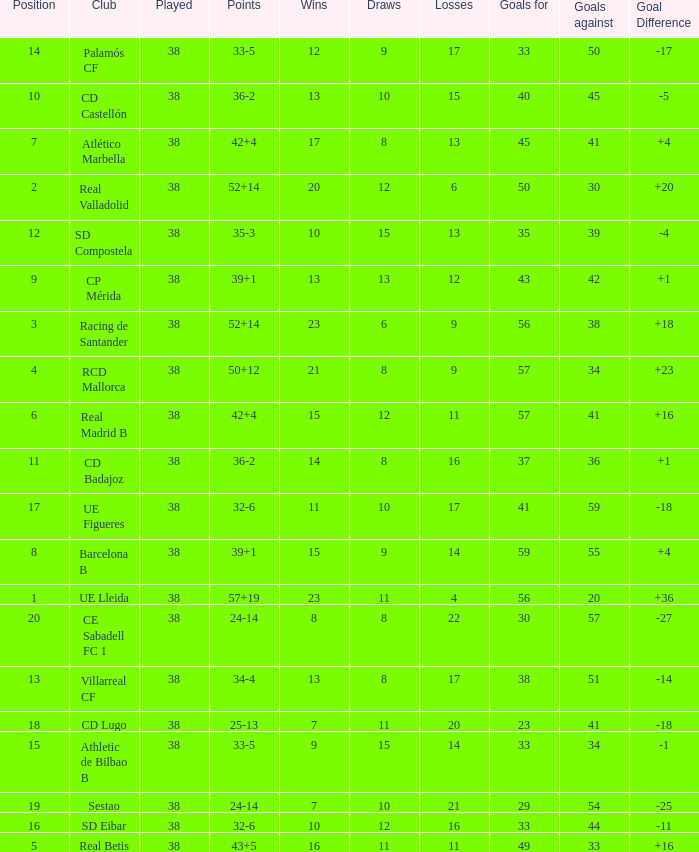What is the highest number of wins with a goal difference less than 4 at the Villarreal CF and more than 38 played? None. 